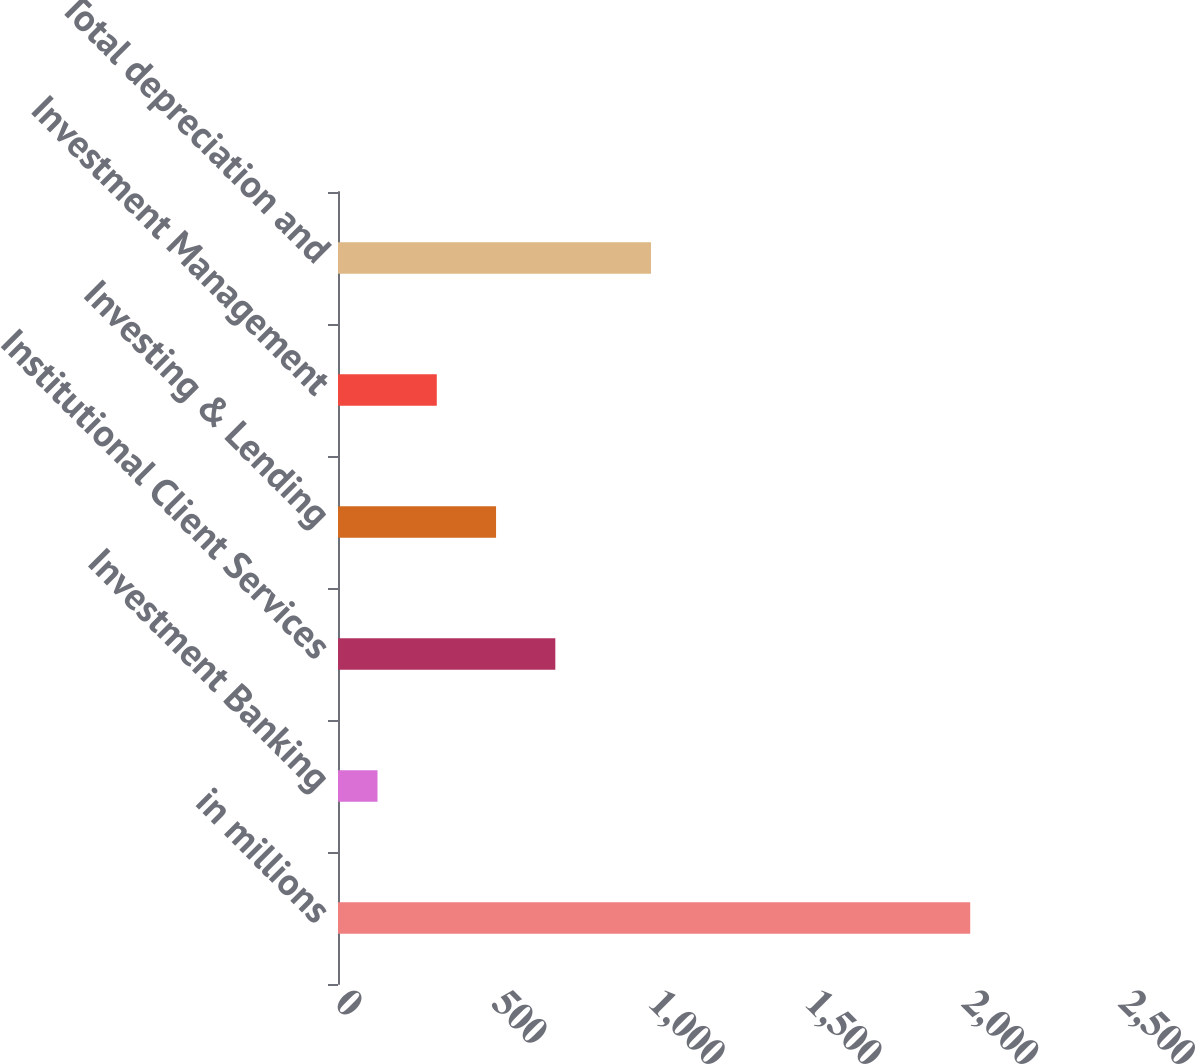<chart> <loc_0><loc_0><loc_500><loc_500><bar_chart><fcel>in millions<fcel>Investment Banking<fcel>Institutional Client Services<fcel>Investing & Lending<fcel>Investment Management<fcel>Total depreciation and<nl><fcel>2016<fcel>126<fcel>693<fcel>504<fcel>315<fcel>998<nl></chart> 